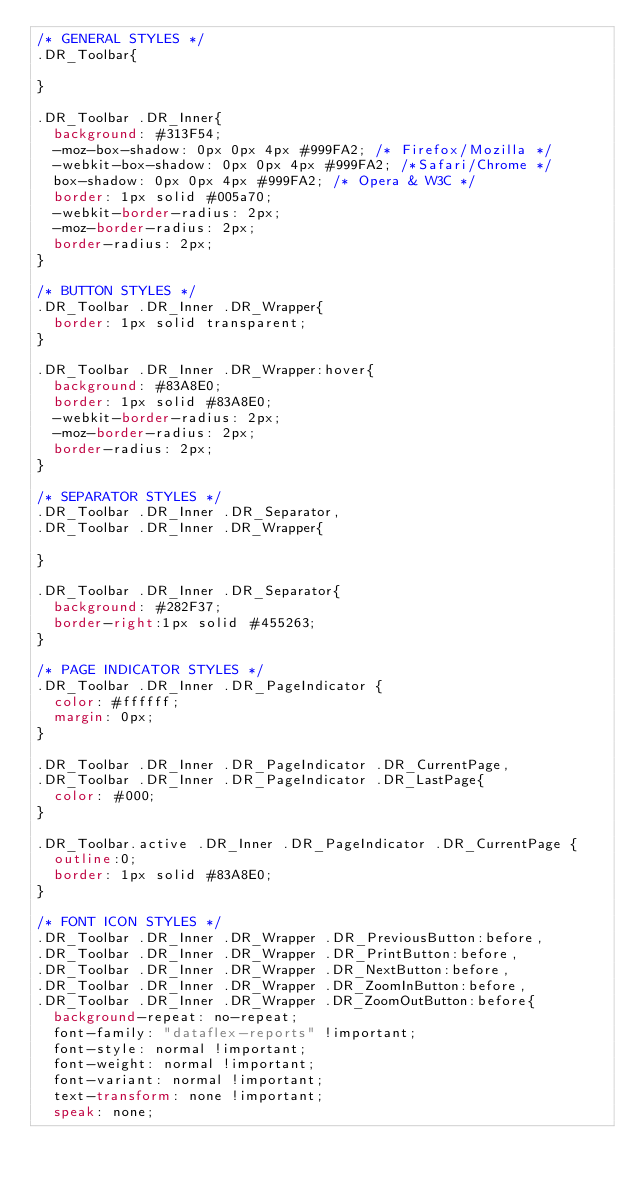<code> <loc_0><loc_0><loc_500><loc_500><_CSS_>/* GENERAL STYLES */
.DR_Toolbar{

}

.DR_Toolbar .DR_Inner{
  background: #313F54;
  -moz-box-shadow: 0px 0px 4px #999FA2; /* Firefox/Mozilla */
  -webkit-box-shadow: 0px 0px 4px #999FA2; /*Safari/Chrome */
  box-shadow: 0px 0px 4px #999FA2; /* Opera & W3C */
  border: 1px solid #005a70;
  -webkit-border-radius: 2px;
  -moz-border-radius: 2px;
  border-radius: 2px;
}

/* BUTTON STYLES */
.DR_Toolbar .DR_Inner .DR_Wrapper{
  border: 1px solid transparent;
}

.DR_Toolbar .DR_Inner .DR_Wrapper:hover{
  background: #83A8E0;
  border: 1px solid #83A8E0;
  -webkit-border-radius: 2px;
  -moz-border-radius: 2px;
  border-radius: 2px;
}

/* SEPARATOR STYLES */
.DR_Toolbar .DR_Inner .DR_Separator, 
.DR_Toolbar .DR_Inner .DR_Wrapper{

}

.DR_Toolbar .DR_Inner .DR_Separator{
  background: #282F37;
  border-right:1px solid #455263;
}

/* PAGE INDICATOR STYLES */
.DR_Toolbar .DR_Inner .DR_PageIndicator {
  color: #ffffff;
  margin: 0px;
}

.DR_Toolbar .DR_Inner .DR_PageIndicator .DR_CurrentPage,
.DR_Toolbar .DR_Inner .DR_PageIndicator .DR_LastPage{
  color: #000;
}

.DR_Toolbar.active .DR_Inner .DR_PageIndicator .DR_CurrentPage {
  outline:0;
  border: 1px solid #83A8E0;
}

/* FONT ICON STYLES */
.DR_Toolbar .DR_Inner .DR_Wrapper .DR_PreviousButton:before, 
.DR_Toolbar .DR_Inner .DR_Wrapper .DR_PrintButton:before, 
.DR_Toolbar .DR_Inner .DR_Wrapper .DR_NextButton:before,
.DR_Toolbar .DR_Inner .DR_Wrapper .DR_ZoomInButton:before,
.DR_Toolbar .DR_Inner .DR_Wrapper .DR_ZoomOutButton:before{
  background-repeat: no-repeat;
  font-family: "dataflex-reports" !important;
  font-style: normal !important;
  font-weight: normal !important;
  font-variant: normal !important;
  text-transform: none !important;
  speak: none;</code> 